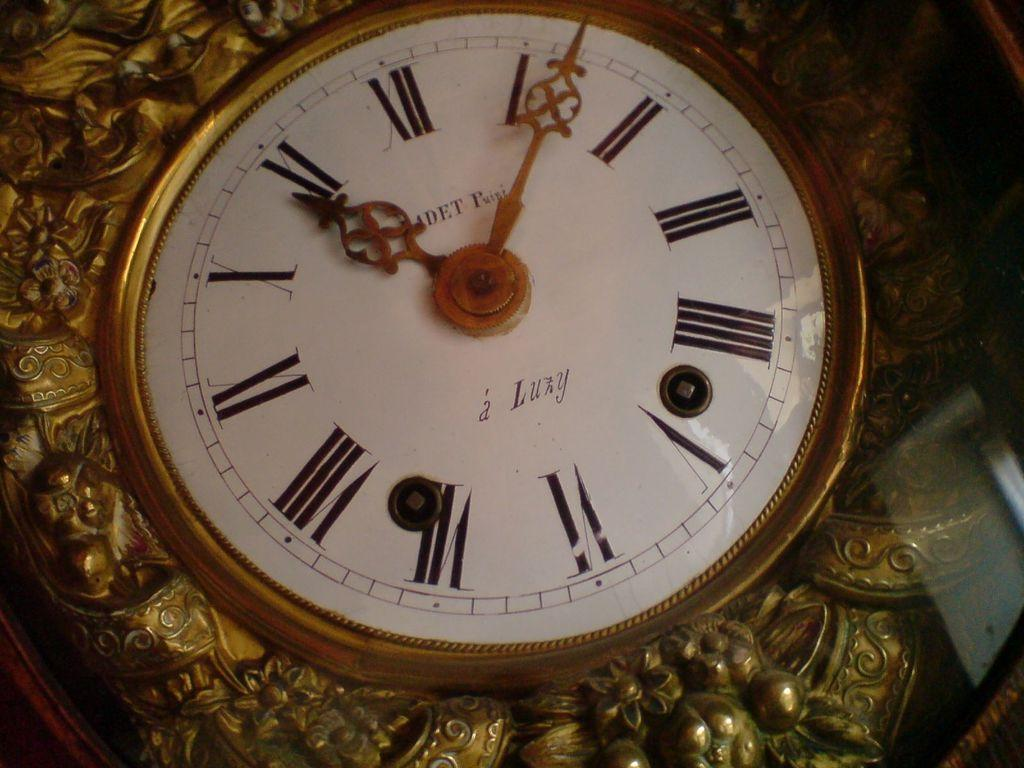<image>
Share a concise interpretation of the image provided. Face of a watch which says "Luxy" on it. 